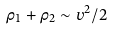Convert formula to latex. <formula><loc_0><loc_0><loc_500><loc_500>\rho _ { 1 } + \rho _ { 2 } \sim v ^ { 2 } / 2</formula> 